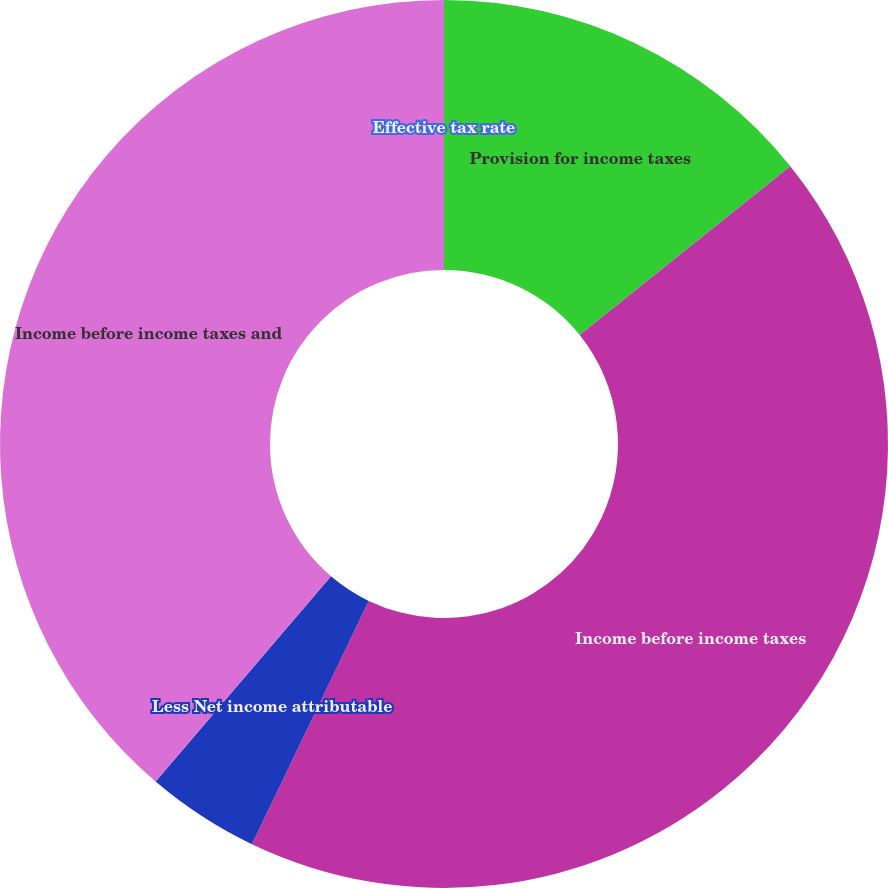Convert chart to OTSL. <chart><loc_0><loc_0><loc_500><loc_500><pie_chart><fcel>Provision for income taxes<fcel>Income before income taxes<fcel>Less Net income attributable<fcel>Income before income taxes and<fcel>Effective tax rate<nl><fcel>14.24%<fcel>42.88%<fcel>4.13%<fcel>38.75%<fcel>0.0%<nl></chart> 